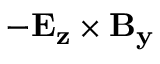<formula> <loc_0><loc_0><loc_500><loc_500>- E _ { z } \times B _ { y }</formula> 